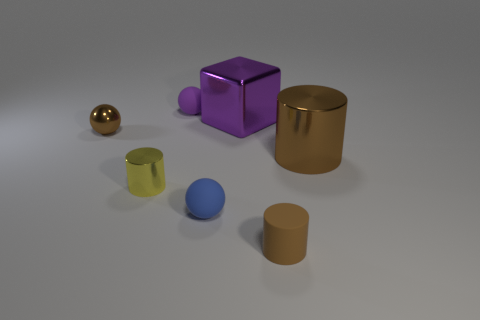How many brown cylinders must be subtracted to get 1 brown cylinders? 1 Add 1 blue spheres. How many objects exist? 8 Subtract all blocks. How many objects are left? 6 Add 6 large shiny balls. How many large shiny balls exist? 6 Subtract 0 gray spheres. How many objects are left? 7 Subtract all big cyan metal cubes. Subtract all tiny objects. How many objects are left? 2 Add 5 tiny brown matte cylinders. How many tiny brown matte cylinders are left? 6 